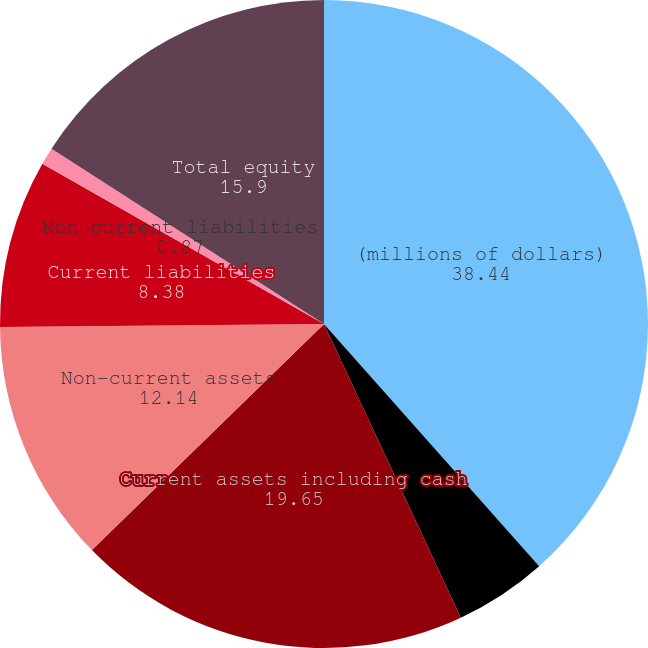Convert chart. <chart><loc_0><loc_0><loc_500><loc_500><pie_chart><fcel>(millions of dollars)<fcel>Cash and securities<fcel>Current assets including cash<fcel>Non-current assets<fcel>Current liabilities<fcel>Non-current liabilities<fcel>Total equity<nl><fcel>38.44%<fcel>4.62%<fcel>19.65%<fcel>12.14%<fcel>8.38%<fcel>0.87%<fcel>15.9%<nl></chart> 